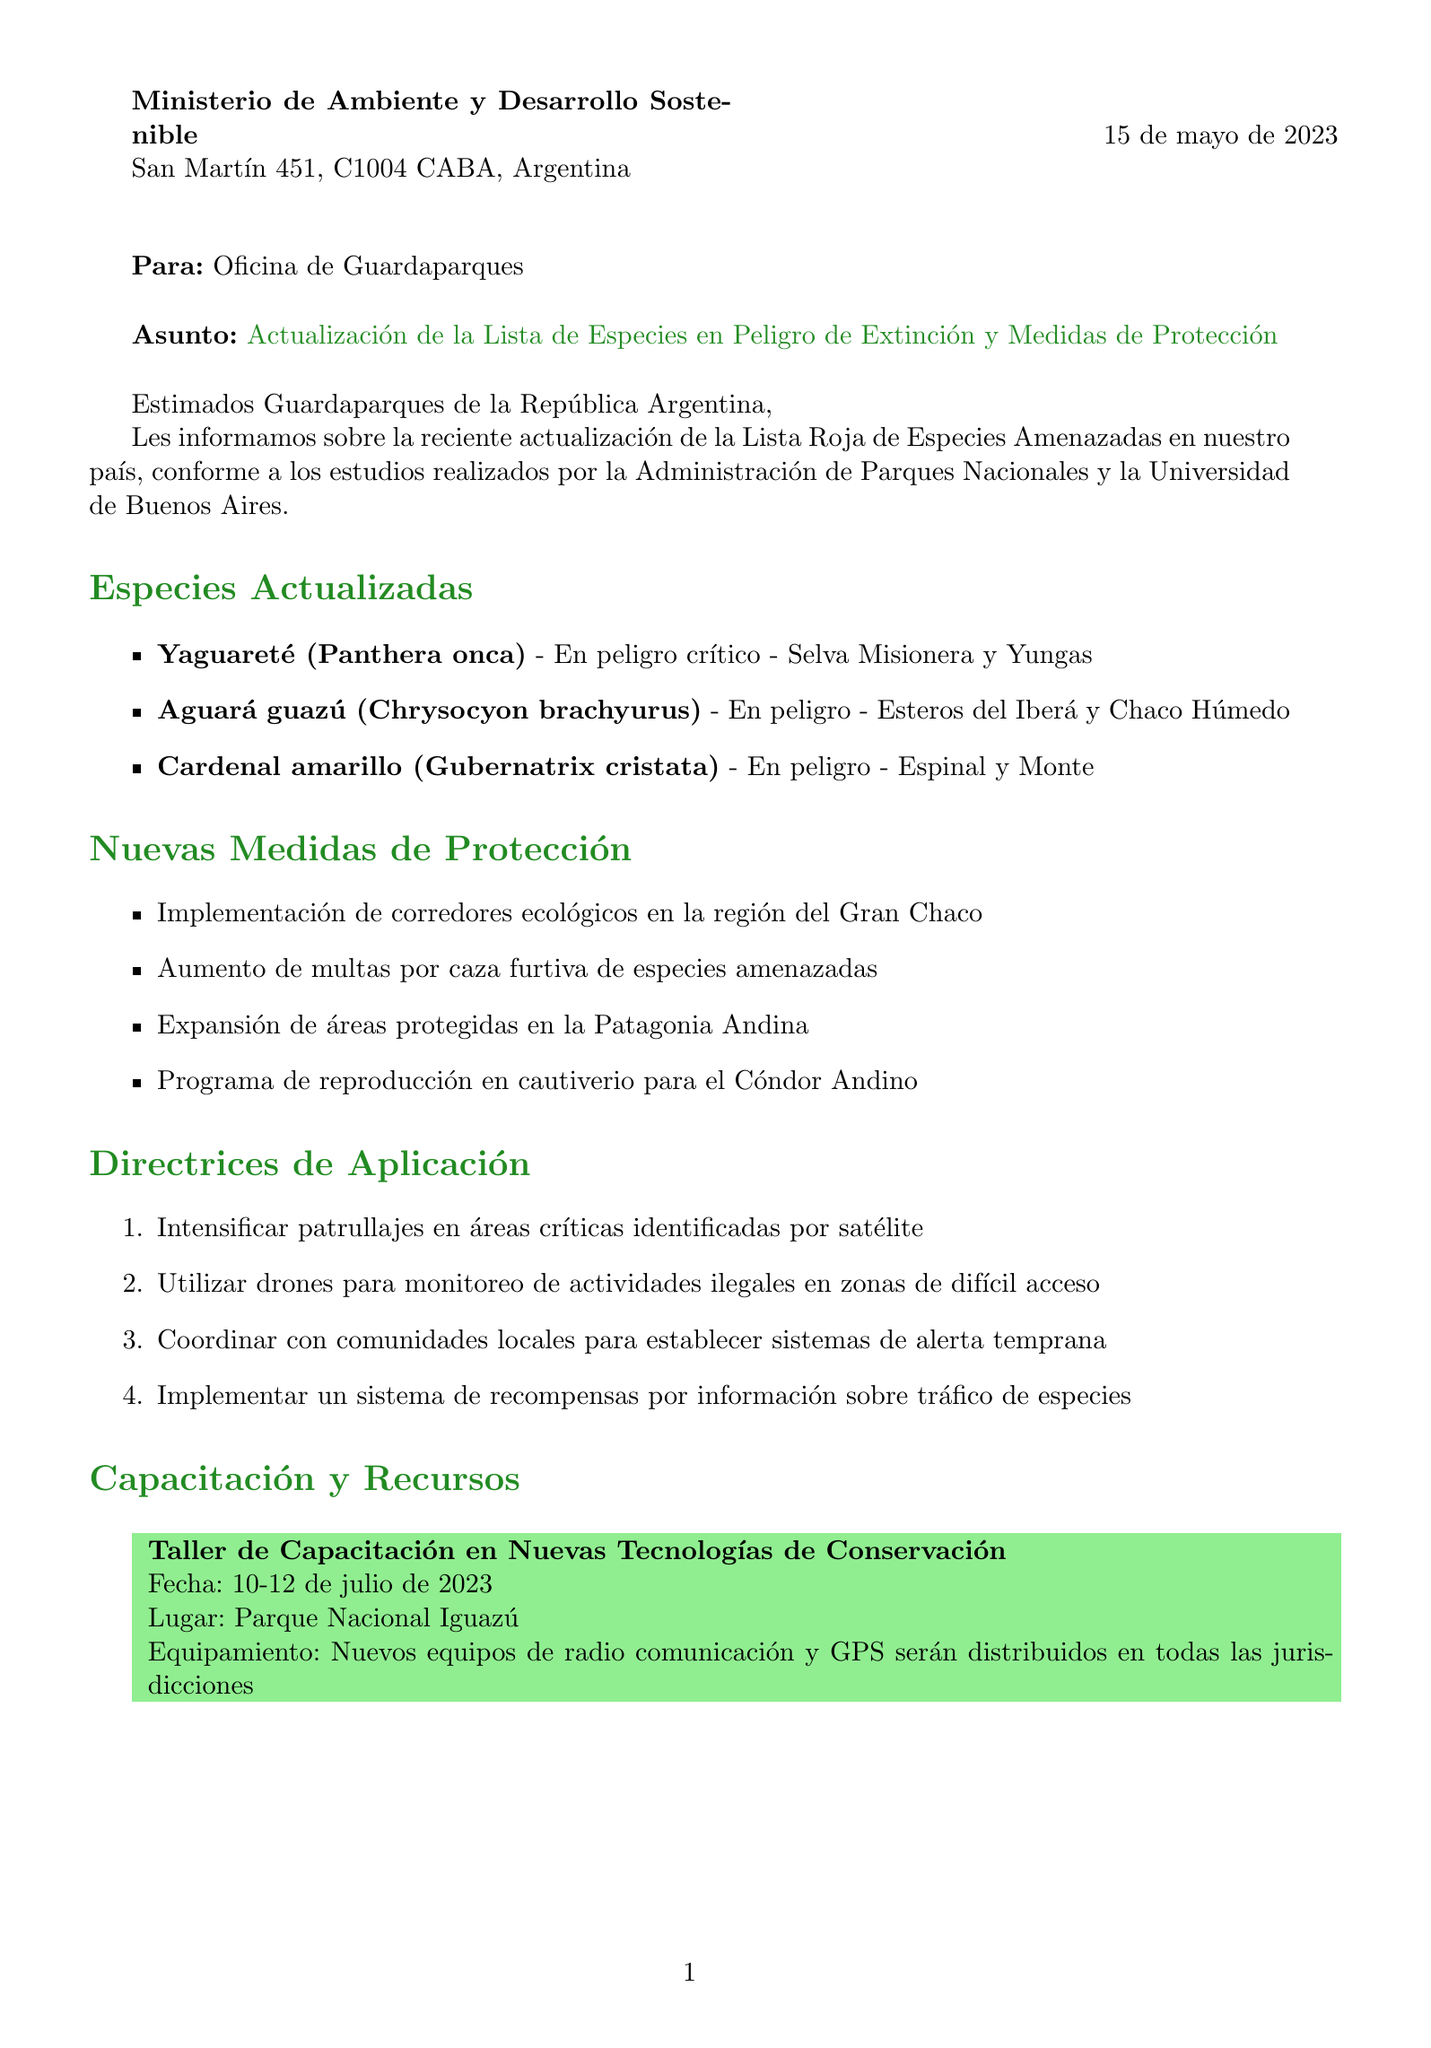what is the date of the letter? The date of the letter is mentioned in the document as when it was sent to the recipient.
Answer: 15 de mayo de 2023 who is the sender of the letter? The letter identifies the sender at the top, in the header section, detailing the organization name.
Answer: Ministerio de Ambiente y Desarrollo Sostenible what status is assigned to Yaguareté? The letter lists the updated status of the Yaguareté in the species update section.
Answer: En peligro crítico what new protection measure involves the Gran Chaco? The new protection measures are listed within the document, one specifically mentions the Gran Chaco.
Answer: Implementación de corredores ecológicos en la región del Gran Chaco how many species were updated in the document? The list of updated species is provided in a specified section, counting those entries gives the total.
Answer: 3 when will the training workshop take place? The date for the training workshop can be found in the training and resources section of the letter.
Answer: 10-12 de julio de 2023 who is the recipient of the letter? The document specifies who the letter is addressed to in the opening part of the letter.
Answer: Oficina de Guardaparques what type of collaboration initiative involves Gendarmería Nacional? This is detailed under the partnership initiatives in the letter, specifically mentioning a collaborative program.
Answer: Programa conjunto con la Gendarmería Nacional para control de fronteras which online method is suggested for monitoring illegal activities? The letter provides a guideline that includes using modern technology for monitoring illegal activities.
Answer: Utilizar drones para monitoreo de actividades ilegales en zonas de difícil acceso 